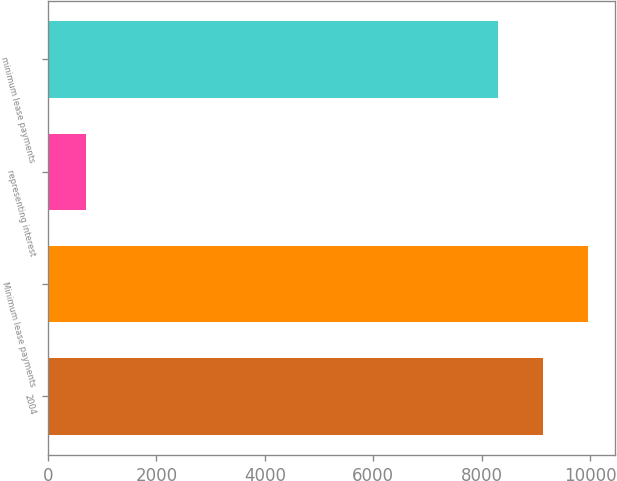Convert chart to OTSL. <chart><loc_0><loc_0><loc_500><loc_500><bar_chart><fcel>2004<fcel>Minimum lease payments<fcel>representing interest<fcel>minimum lease payments<nl><fcel>9124.5<fcel>9954<fcel>705<fcel>8295<nl></chart> 